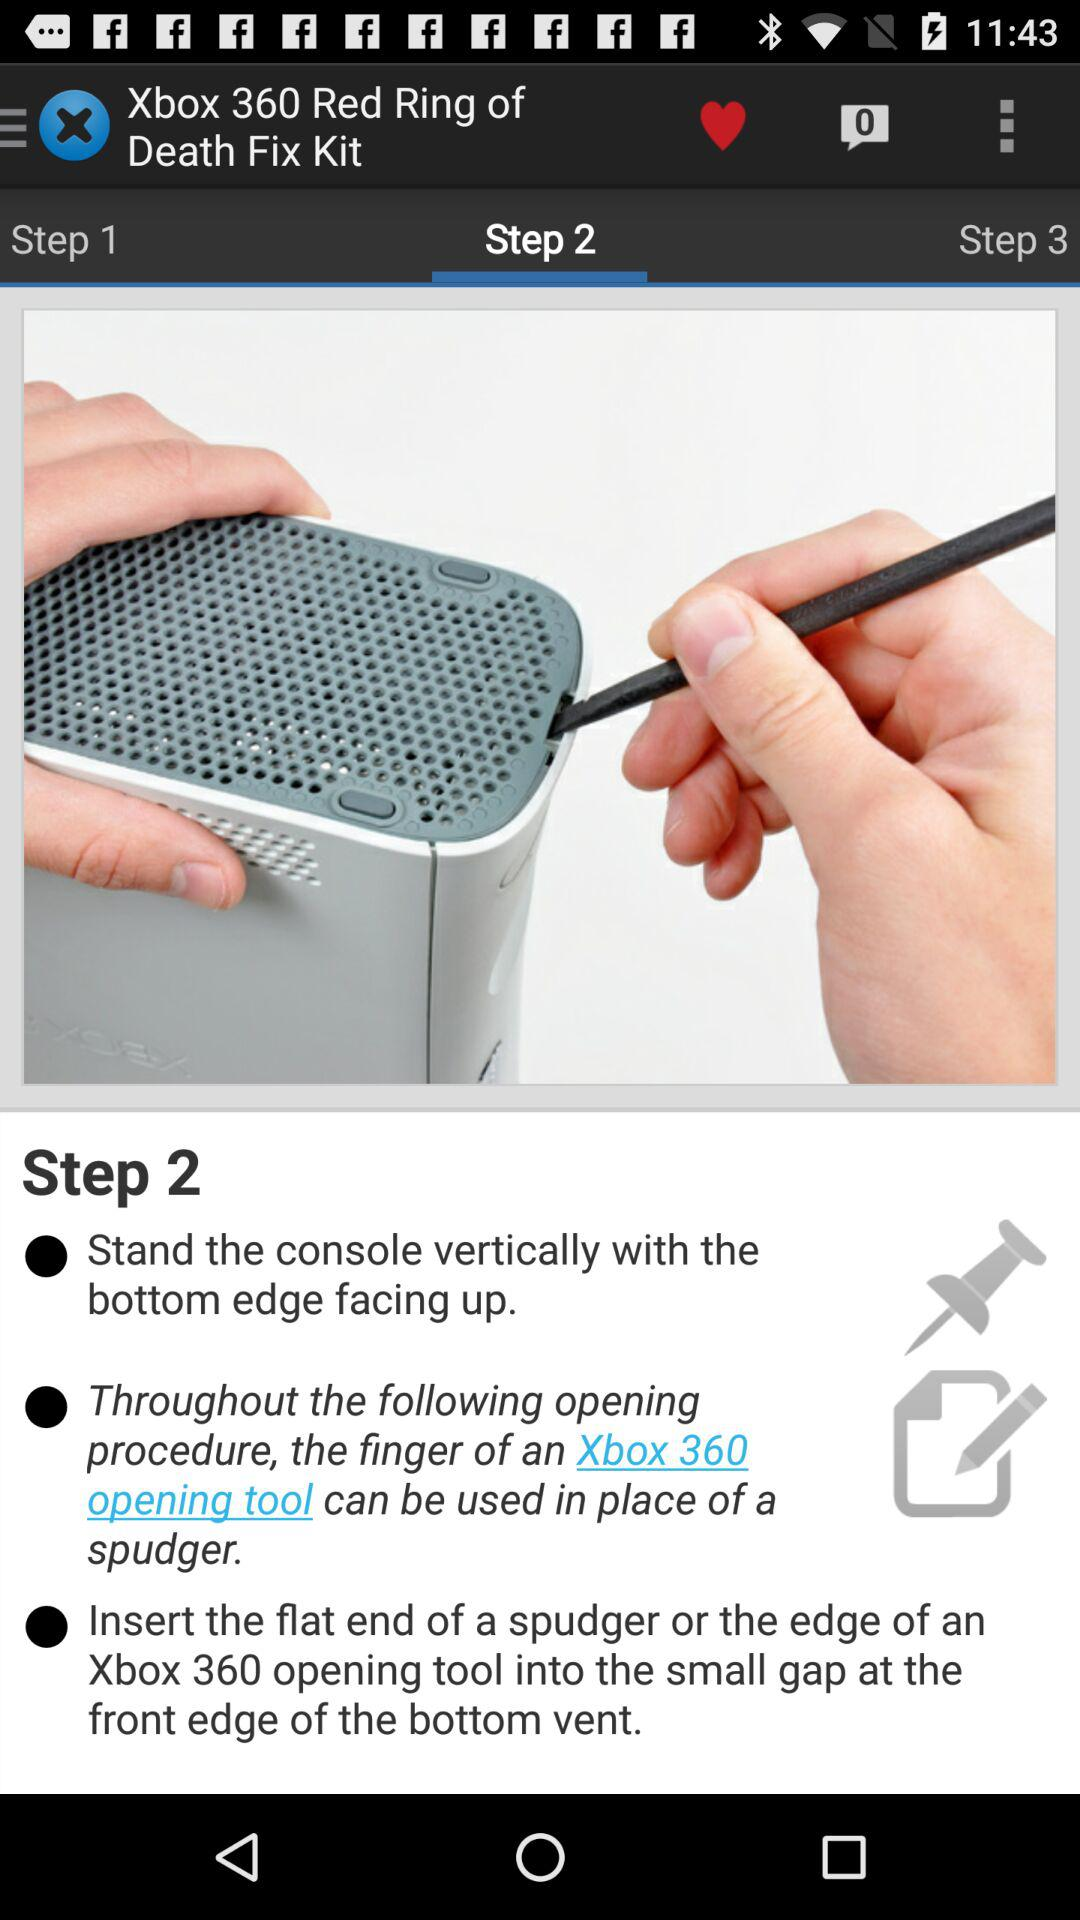How many notifications are pending in messages? There is 0 pending notification. 